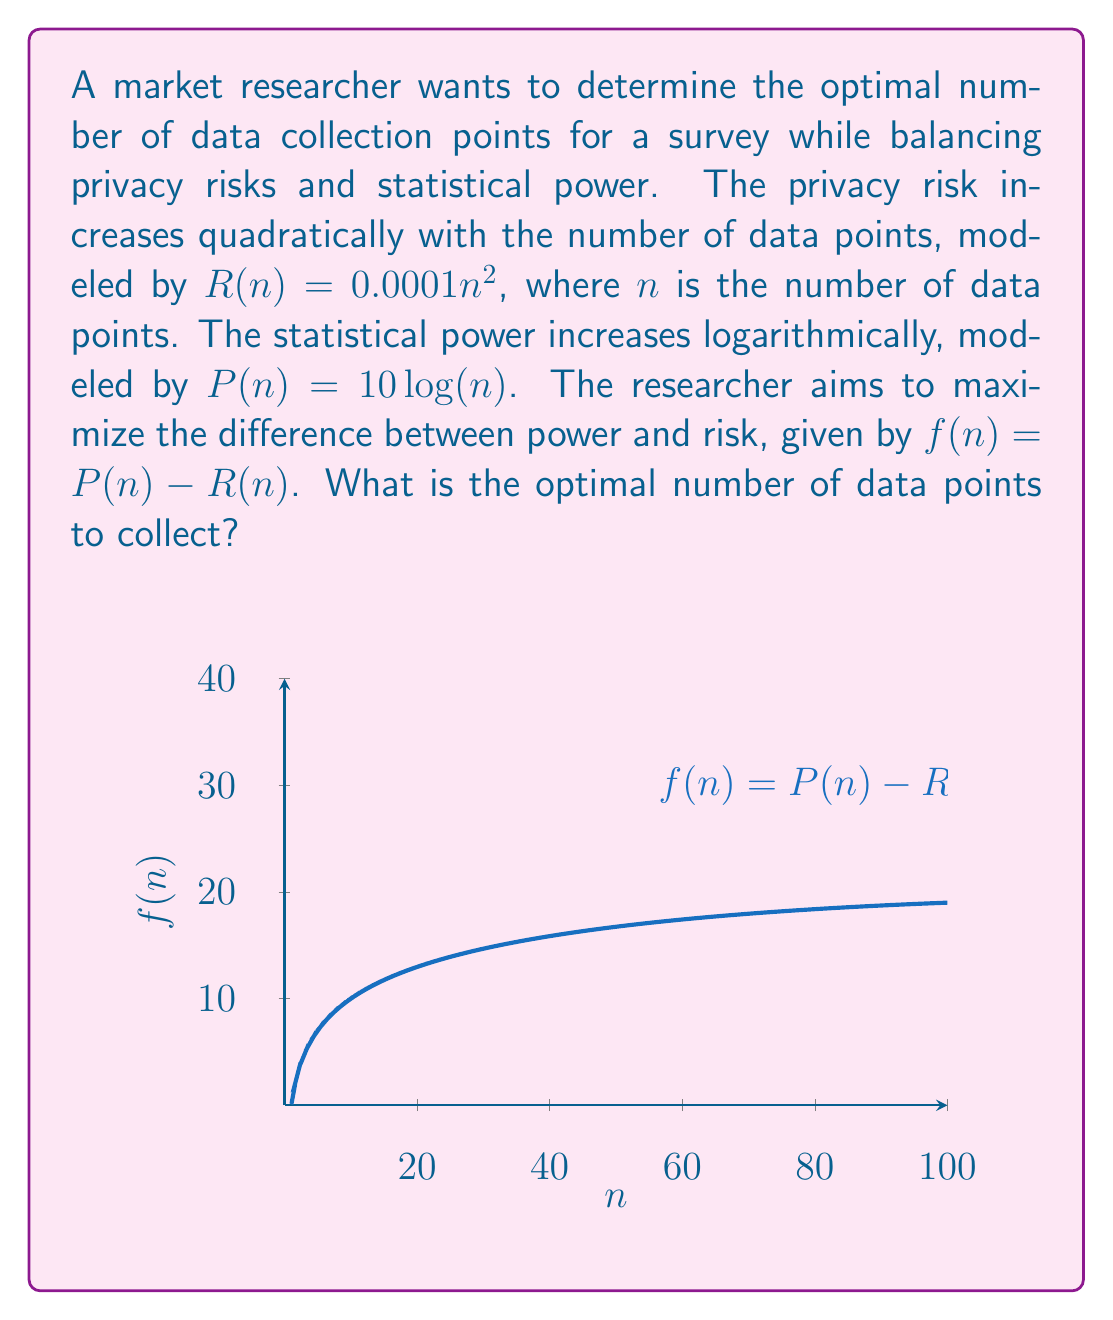Provide a solution to this math problem. To find the optimal number of data points, we need to maximize the function $f(n) = P(n) - R(n)$:

1) First, express $f(n)$ in terms of $n$:
   $f(n) = 10\log(n) - 0.0001n^2$

2) To find the maximum, differentiate $f(n)$ with respect to $n$ and set it to zero:
   $$\frac{df}{dn} = \frac{10}{n} - 0.0002n = 0$$

3) Solve the equation:
   $$\frac{10}{n} = 0.0002n$$
   $$10 = 0.0002n^2$$
   $$n^2 = \frac{10}{0.0002} = 50000$$
   $$n = \sqrt{50000} \approx 223.61$$

4) To confirm this is a maximum, check the second derivative:
   $$\frac{d^2f}{dn^2} = -\frac{10}{n^2} - 0.0002 < 0$$
   This is negative for all positive $n$, confirming a maximum.

5) Since $n$ must be a whole number, we round to the nearest integer:
   $n = 224$

Therefore, the optimal number of data points to collect is 224.
Answer: 224 data points 